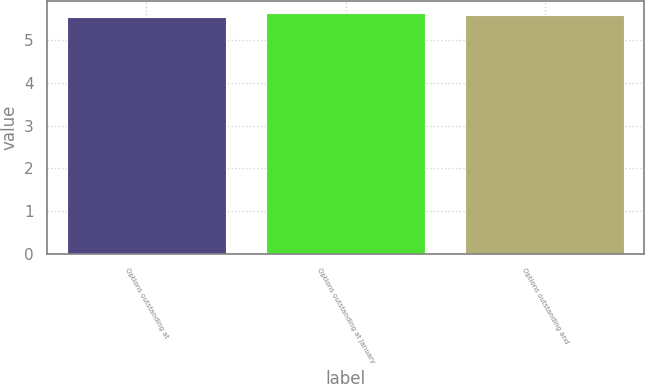<chart> <loc_0><loc_0><loc_500><loc_500><bar_chart><fcel>Options outstanding at<fcel>Options outstanding at January<fcel>Options outstanding and<nl><fcel>5.53<fcel>5.62<fcel>5.57<nl></chart> 